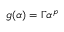Convert formula to latex. <formula><loc_0><loc_0><loc_500><loc_500>g ( \alpha ) = \Gamma \alpha ^ { p }</formula> 